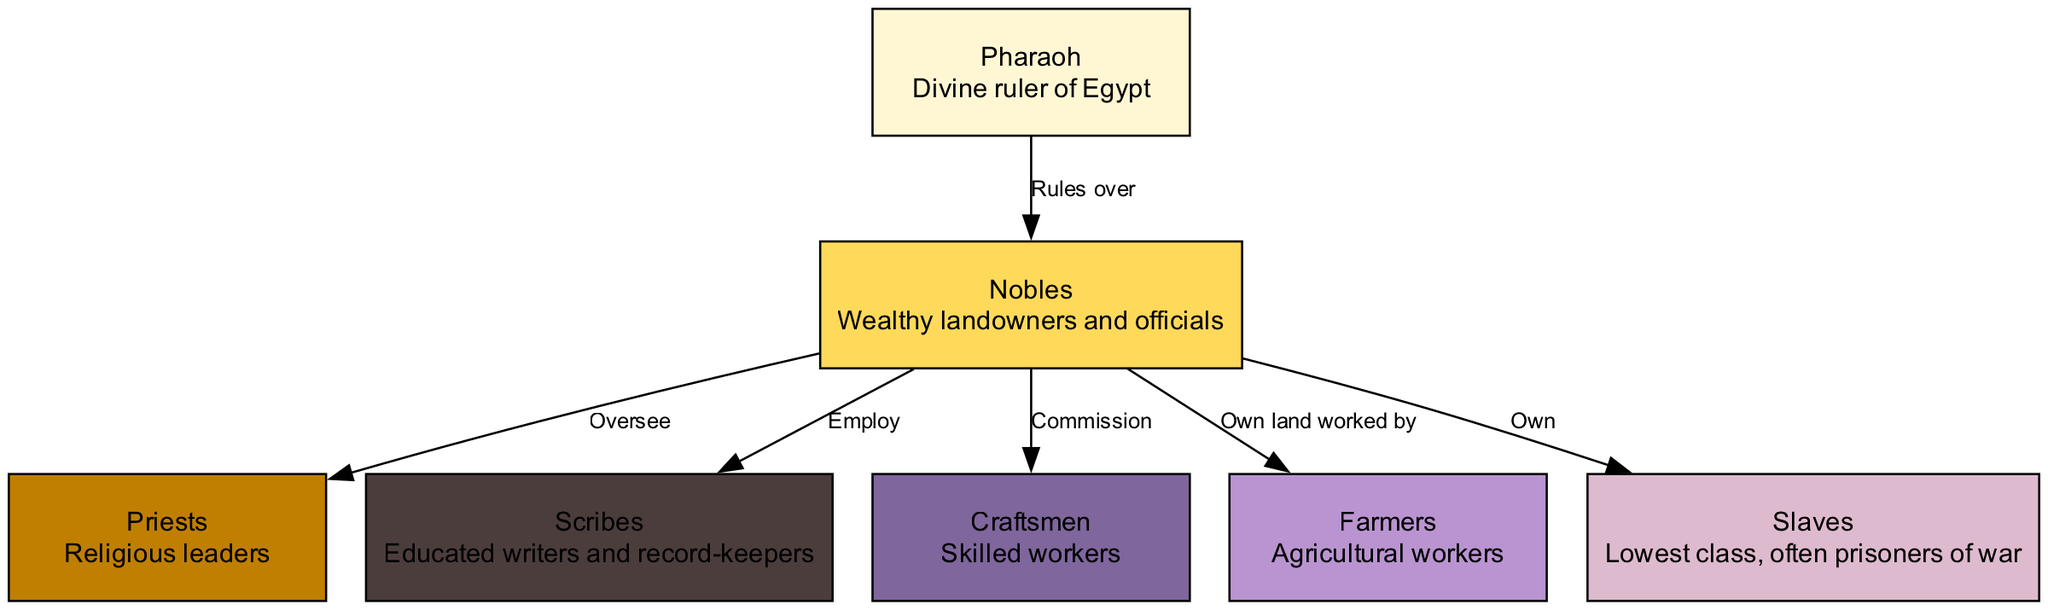What is the highest class in the diagram? The diagram shows the class hierarchy starting from the Pharaoh at the top. This can be identified by the positioning of the nodes, as the Pharaoh is the first node and has no node above it.
Answer: Pharaoh How many classes are represented in the diagram? By counting the nodes listed in the diagram, we find that there are a total of 7 nodes representing different classes, which illustrates the complete hierarchy.
Answer: 7 Who does the Pharaoh rule over? The edge from the Pharaoh to the Nobles specifically states "Rules over," indicating that the Pharaoh has authority over this class.
Answer: Nobles Which class oversees the Priests? From the connections, we can see that the Nobles have an edge that states "Oversee" directed toward the Priests. This implies that Nobles maintain authority over them.
Answer: Nobles What is the relationship between Nobles and Slaves? The edge from Nobles to Slaves indicates the relationship "Own," which signifies that Nobles own Slaves in the social hierarchy depicted in the diagram.
Answer: Own How many edges are shown in the diagram? By examining the edges that connect the various nodes, we can count a total of 6 edges in the diagram that represent the relationships between the classes.
Answer: 6 What do Scribes do within their social context? According to the edge from Nobles to Scribes labeled "Employ," it is indicated that Scribes are employed by the Nobles, defining their role within the social structure.
Answer: Employ Which class has the lowest social status? The description associated with the Slaves node tells us that they are the "Lowest class," making it clear that this is the class with the least social standing in the hierarchy.
Answer: Slaves What is the function of Craftsmen in relation to Nobles? The diagram specifies that Nobles "Commission" Craftsmen, meaning that Craftsmen are hired to perform specific tasks or create goods for the Nobles.
Answer: Commission 